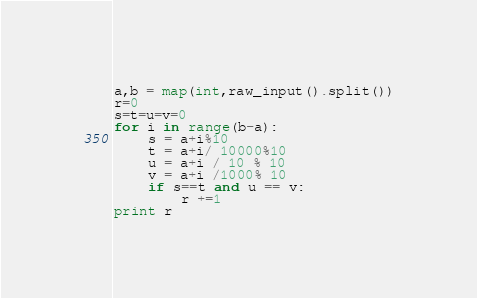Convert code to text. <code><loc_0><loc_0><loc_500><loc_500><_Python_>a,b = map(int,raw_input().split())
r=0
s=t=u=v=0
for i in range(b-a):
	s = a+i%10
	t = a+i/ 10000%10
	u = a+i / 10 % 10
	v = a+i /1000% 10
	if s==t and u == v:
		r +=1
print r </code> 